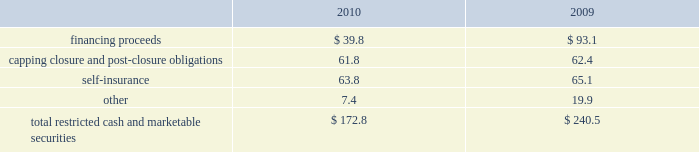At december 31 .
The table summarizes our restricted cash and marketable securities as of december .
We own a 19.9% ( 19.9 % ) interest in a company that , among other activities , issues financial surety bonds to secure capping , closure and post-closure obligations for companies operating in the solid waste industry .
We account for this investment under the cost method of accounting .
There have been no identified events or changes in circumstances that may have a significant adverse effect on the fair value of the investment .
This investee company and the parent company of the investee had written surety bonds for us relating to our landfill operations for capping , closure and post-closure , of which $ 855.0 million and $ 775.2 million were outstanding as of december 31 , 2010 and 2009 , respectively .
Our reimbursement obligations under these bonds are secured by an indemnity agreement with the investee and letters of credit totaling $ 45.0 million and $ 67.4 million as of december 31 , 2010 and 2009 , respectively .
Off-balance sheet arrangements we have no off-balance sheet debt or similar obligations , other than operating leases and the financial assurances discussed above , which are not classified as debt .
We have no transactions or obligations with related parties that are not disclosed , consolidated into or reflected in our reported financial position or results of operations .
We have not guaranteed any third-party debt .
Guarantees we enter into contracts in the normal course of business that include indemnification clauses .
Indemnifications relating to known liabilities are recorded in the consolidated financial statements based on our best estimate of required future payments .
Certain of these indemnifications relate to contingent events or occurrences , such as the imposition of additional taxes due to a change in the tax law or adverse interpretation of the tax law , and indemnifications made in divestiture agreements where we indemnify the buyer for liabilities that relate to our activities prior to the divestiture and that may become known in the future .
We do not believe that these contingent obligations will have a material effect on our consolidated financial position , results of operations or cash flows .
We have entered into agreements with property owners to guarantee the value of property that is adjacent to certain of our landfills .
These agreements have varying terms .
We do not believe that these contingent obligations will have a material effect on our consolidated financial position , results of operations or cash flows .
Other matters our business activities are conducted in the context of a developing and changing statutory and regulatory framework .
Governmental regulation of the waste management industry requires us to obtain and retain numerous governmental permits to conduct various aspects of our operations .
These permits are subject to revocation , modification or denial .
The costs and other capital expenditures which may be required to obtain or retain the applicable permits or comply with applicable regulations could be significant .
Any revocation , modification or denial of permits could have a material adverse effect on us .
Republic services , inc .
Notes to consolidated financial statements , continued .
What was the ratio of the outstanding surety bonds for the investee and the parent for 2010 to 2009? 
Rationale: the ratio of the outstanding surety bonds for the investee and the parent for 2010 to 2009 was 1.1
Computations: (855.0 / 775.2)
Answer: 1.10294. 